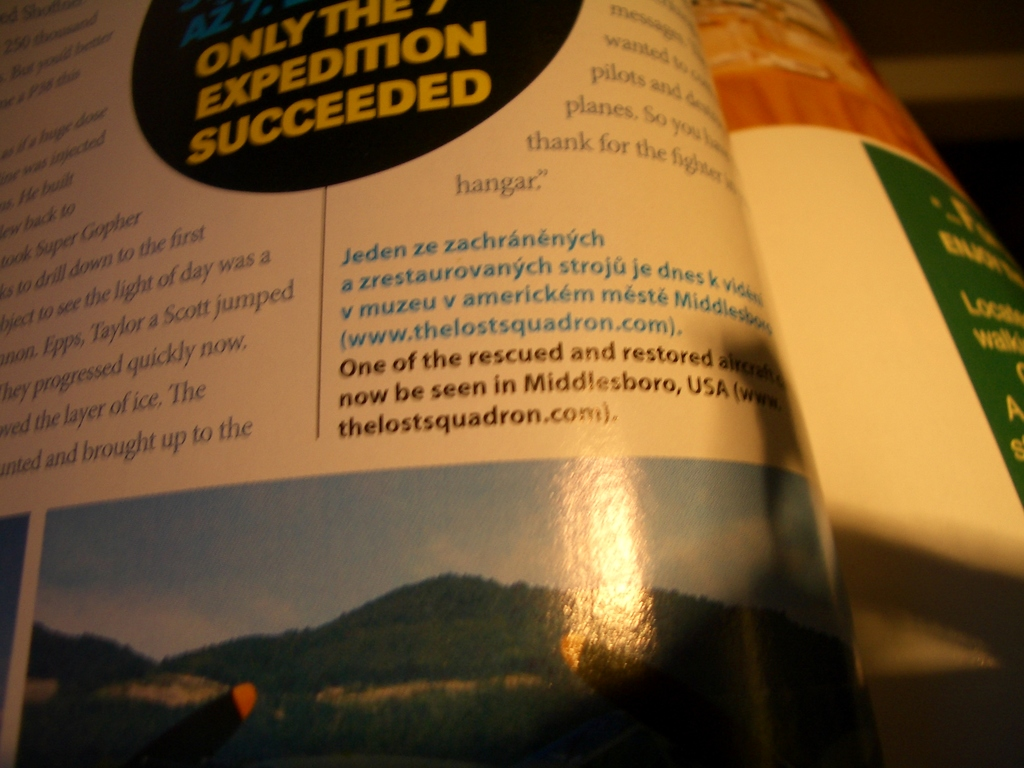Can you tell more about the airplane visible in the lower part of the image? The airplane shown is likely one of the restored aircraft from the expeditions mentioned. It appears to be a World War II era fighter, characterized by its distinct nose art and vintage design, emphasizing the era's unique aviation aesthetics. 